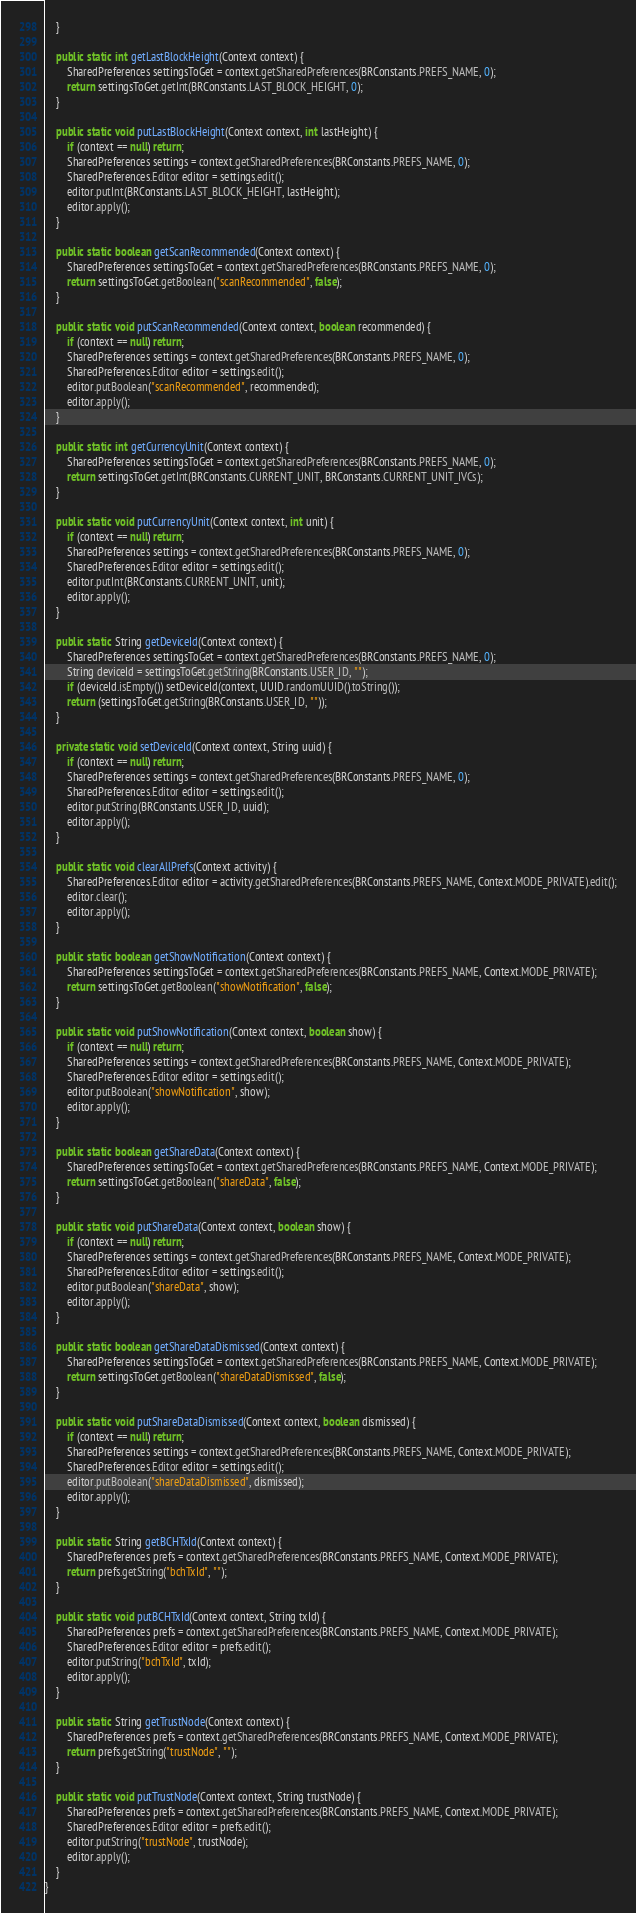<code> <loc_0><loc_0><loc_500><loc_500><_Java_>    }

    public static int getLastBlockHeight(Context context) {
        SharedPreferences settingsToGet = context.getSharedPreferences(BRConstants.PREFS_NAME, 0);
        return settingsToGet.getInt(BRConstants.LAST_BLOCK_HEIGHT, 0);
    }

    public static void putLastBlockHeight(Context context, int lastHeight) {
        if (context == null) return;
        SharedPreferences settings = context.getSharedPreferences(BRConstants.PREFS_NAME, 0);
        SharedPreferences.Editor editor = settings.edit();
        editor.putInt(BRConstants.LAST_BLOCK_HEIGHT, lastHeight);
        editor.apply();
    }

    public static boolean getScanRecommended(Context context) {
        SharedPreferences settingsToGet = context.getSharedPreferences(BRConstants.PREFS_NAME, 0);
        return settingsToGet.getBoolean("scanRecommended", false);
    }

    public static void putScanRecommended(Context context, boolean recommended) {
        if (context == null) return;
        SharedPreferences settings = context.getSharedPreferences(BRConstants.PREFS_NAME, 0);
        SharedPreferences.Editor editor = settings.edit();
        editor.putBoolean("scanRecommended", recommended);
        editor.apply();
    }

    public static int getCurrencyUnit(Context context) {
        SharedPreferences settingsToGet = context.getSharedPreferences(BRConstants.PREFS_NAME, 0);
        return settingsToGet.getInt(BRConstants.CURRENT_UNIT, BRConstants.CURRENT_UNIT_IVCs);
    }

    public static void putCurrencyUnit(Context context, int unit) {
        if (context == null) return;
        SharedPreferences settings = context.getSharedPreferences(BRConstants.PREFS_NAME, 0);
        SharedPreferences.Editor editor = settings.edit();
        editor.putInt(BRConstants.CURRENT_UNIT, unit);
        editor.apply();
    }

    public static String getDeviceId(Context context) {
        SharedPreferences settingsToGet = context.getSharedPreferences(BRConstants.PREFS_NAME, 0);
        String deviceId = settingsToGet.getString(BRConstants.USER_ID, "");
        if (deviceId.isEmpty()) setDeviceId(context, UUID.randomUUID().toString());
        return (settingsToGet.getString(BRConstants.USER_ID, ""));
    }

    private static void setDeviceId(Context context, String uuid) {
        if (context == null) return;
        SharedPreferences settings = context.getSharedPreferences(BRConstants.PREFS_NAME, 0);
        SharedPreferences.Editor editor = settings.edit();
        editor.putString(BRConstants.USER_ID, uuid);
        editor.apply();
    }

    public static void clearAllPrefs(Context activity) {
        SharedPreferences.Editor editor = activity.getSharedPreferences(BRConstants.PREFS_NAME, Context.MODE_PRIVATE).edit();
        editor.clear();
        editor.apply();
    }

    public static boolean getShowNotification(Context context) {
        SharedPreferences settingsToGet = context.getSharedPreferences(BRConstants.PREFS_NAME, Context.MODE_PRIVATE);
        return settingsToGet.getBoolean("showNotification", false);
    }

    public static void putShowNotification(Context context, boolean show) {
        if (context == null) return;
        SharedPreferences settings = context.getSharedPreferences(BRConstants.PREFS_NAME, Context.MODE_PRIVATE);
        SharedPreferences.Editor editor = settings.edit();
        editor.putBoolean("showNotification", show);
        editor.apply();
    }

    public static boolean getShareData(Context context) {
        SharedPreferences settingsToGet = context.getSharedPreferences(BRConstants.PREFS_NAME, Context.MODE_PRIVATE);
        return settingsToGet.getBoolean("shareData", false);
    }

    public static void putShareData(Context context, boolean show) {
        if (context == null) return;
        SharedPreferences settings = context.getSharedPreferences(BRConstants.PREFS_NAME, Context.MODE_PRIVATE);
        SharedPreferences.Editor editor = settings.edit();
        editor.putBoolean("shareData", show);
        editor.apply();
    }

    public static boolean getShareDataDismissed(Context context) {
        SharedPreferences settingsToGet = context.getSharedPreferences(BRConstants.PREFS_NAME, Context.MODE_PRIVATE);
        return settingsToGet.getBoolean("shareDataDismissed", false);
    }

    public static void putShareDataDismissed(Context context, boolean dismissed) {
        if (context == null) return;
        SharedPreferences settings = context.getSharedPreferences(BRConstants.PREFS_NAME, Context.MODE_PRIVATE);
        SharedPreferences.Editor editor = settings.edit();
        editor.putBoolean("shareDataDismissed", dismissed);
        editor.apply();
    }

    public static String getBCHTxId(Context context) {
        SharedPreferences prefs = context.getSharedPreferences(BRConstants.PREFS_NAME, Context.MODE_PRIVATE);
        return prefs.getString("bchTxId", "");
    }

    public static void putBCHTxId(Context context, String txId) {
        SharedPreferences prefs = context.getSharedPreferences(BRConstants.PREFS_NAME, Context.MODE_PRIVATE);
        SharedPreferences.Editor editor = prefs.edit();
        editor.putString("bchTxId", txId);
        editor.apply();
    }

    public static String getTrustNode(Context context) {
        SharedPreferences prefs = context.getSharedPreferences(BRConstants.PREFS_NAME, Context.MODE_PRIVATE);
        return prefs.getString("trustNode", "");
    }

    public static void putTrustNode(Context context, String trustNode) {
        SharedPreferences prefs = context.getSharedPreferences(BRConstants.PREFS_NAME, Context.MODE_PRIVATE);
        SharedPreferences.Editor editor = prefs.edit();
        editor.putString("trustNode", trustNode);
        editor.apply();
    }
}</code> 